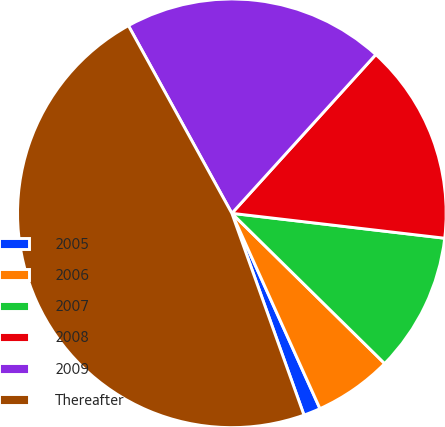Convert chart to OTSL. <chart><loc_0><loc_0><loc_500><loc_500><pie_chart><fcel>2005<fcel>2006<fcel>2007<fcel>2008<fcel>2009<fcel>Thereafter<nl><fcel>1.28%<fcel>5.89%<fcel>10.51%<fcel>15.13%<fcel>19.74%<fcel>47.44%<nl></chart> 